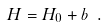Convert formula to latex. <formula><loc_0><loc_0><loc_500><loc_500>H = H _ { 0 } + b \ .</formula> 